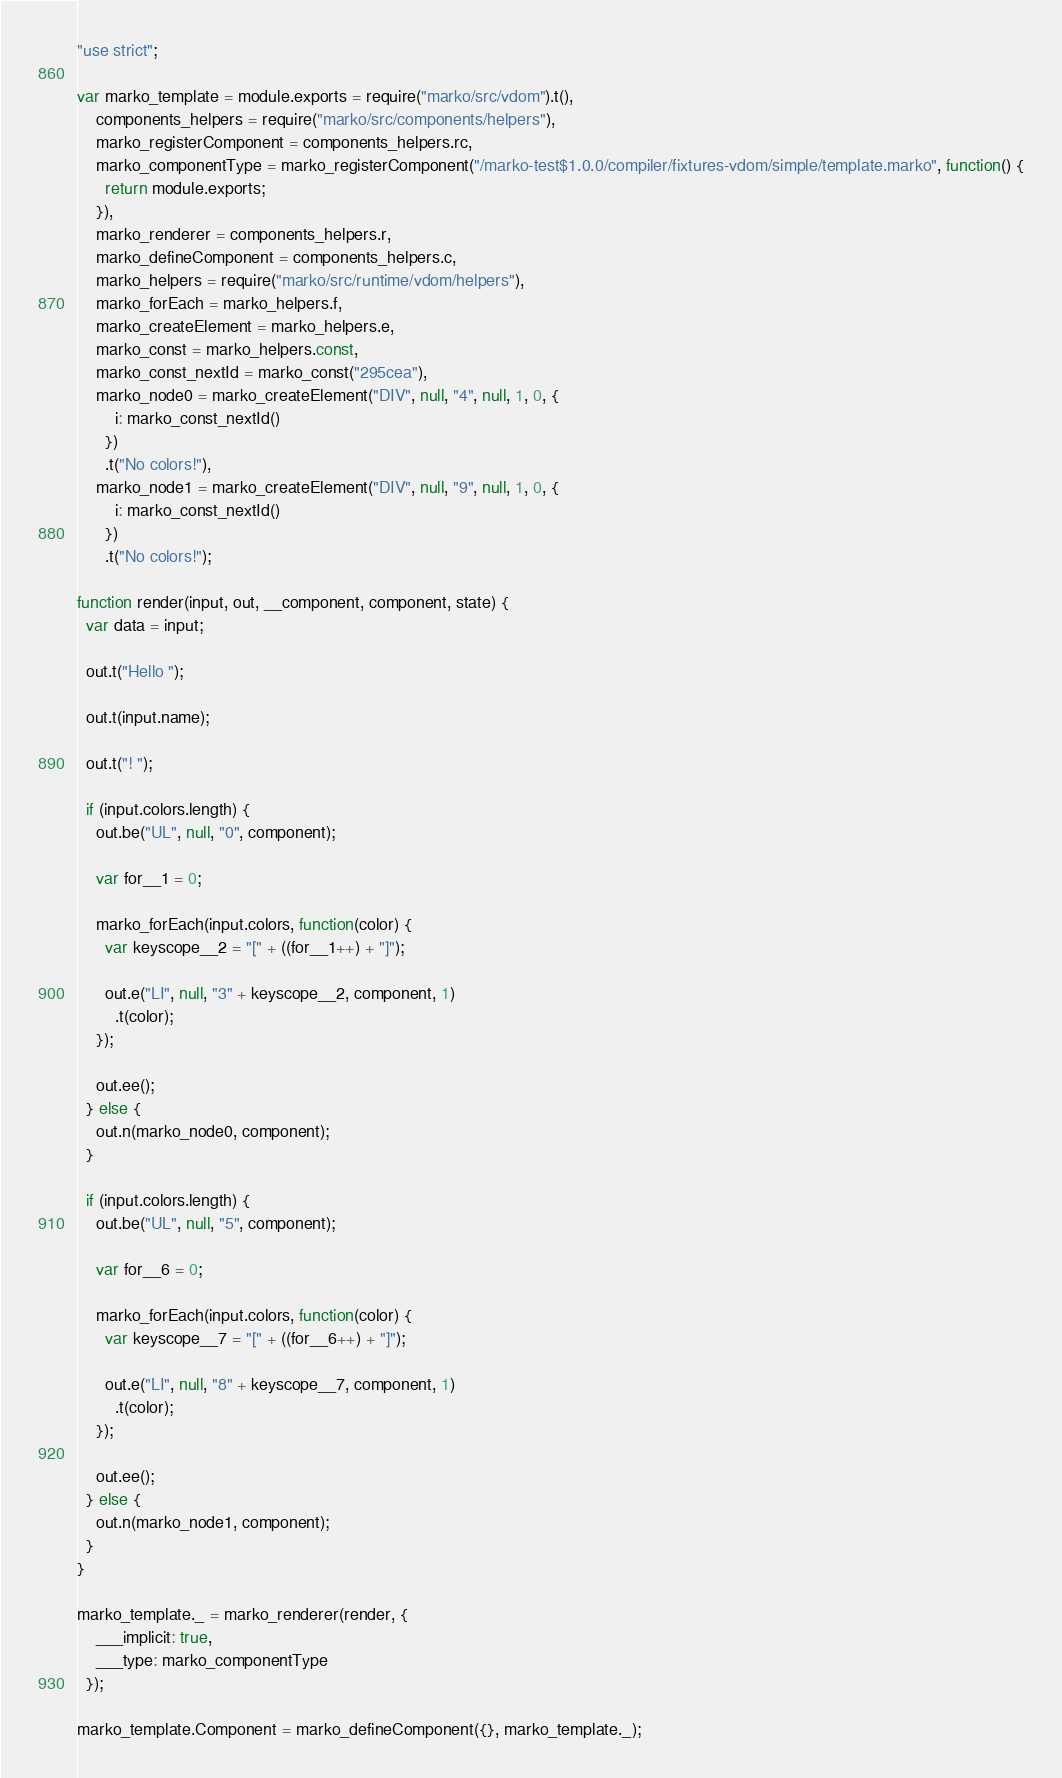Convert code to text. <code><loc_0><loc_0><loc_500><loc_500><_JavaScript_>"use strict";

var marko_template = module.exports = require("marko/src/vdom").t(),
    components_helpers = require("marko/src/components/helpers"),
    marko_registerComponent = components_helpers.rc,
    marko_componentType = marko_registerComponent("/marko-test$1.0.0/compiler/fixtures-vdom/simple/template.marko", function() {
      return module.exports;
    }),
    marko_renderer = components_helpers.r,
    marko_defineComponent = components_helpers.c,
    marko_helpers = require("marko/src/runtime/vdom/helpers"),
    marko_forEach = marko_helpers.f,
    marko_createElement = marko_helpers.e,
    marko_const = marko_helpers.const,
    marko_const_nextId = marko_const("295cea"),
    marko_node0 = marko_createElement("DIV", null, "4", null, 1, 0, {
        i: marko_const_nextId()
      })
      .t("No colors!"),
    marko_node1 = marko_createElement("DIV", null, "9", null, 1, 0, {
        i: marko_const_nextId()
      })
      .t("No colors!");

function render(input, out, __component, component, state) {
  var data = input;

  out.t("Hello ");

  out.t(input.name);

  out.t("! ");

  if (input.colors.length) {
    out.be("UL", null, "0", component);

    var for__1 = 0;

    marko_forEach(input.colors, function(color) {
      var keyscope__2 = "[" + ((for__1++) + "]");

      out.e("LI", null, "3" + keyscope__2, component, 1)
        .t(color);
    });

    out.ee();
  } else {
    out.n(marko_node0, component);
  }

  if (input.colors.length) {
    out.be("UL", null, "5", component);

    var for__6 = 0;

    marko_forEach(input.colors, function(color) {
      var keyscope__7 = "[" + ((for__6++) + "]");

      out.e("LI", null, "8" + keyscope__7, component, 1)
        .t(color);
    });

    out.ee();
  } else {
    out.n(marko_node1, component);
  }
}

marko_template._ = marko_renderer(render, {
    ___implicit: true,
    ___type: marko_componentType
  });

marko_template.Component = marko_defineComponent({}, marko_template._);
</code> 